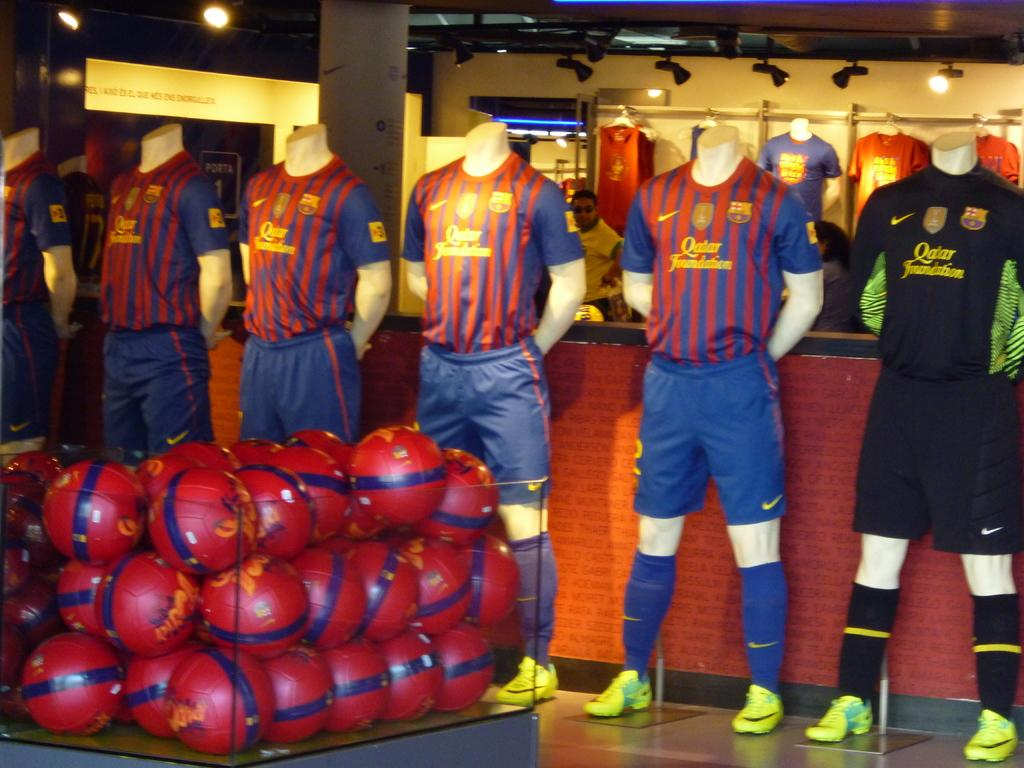<image>
Write a terse but informative summary of the picture. Several soccer jersey for Qatar are displayed on mannequins. 